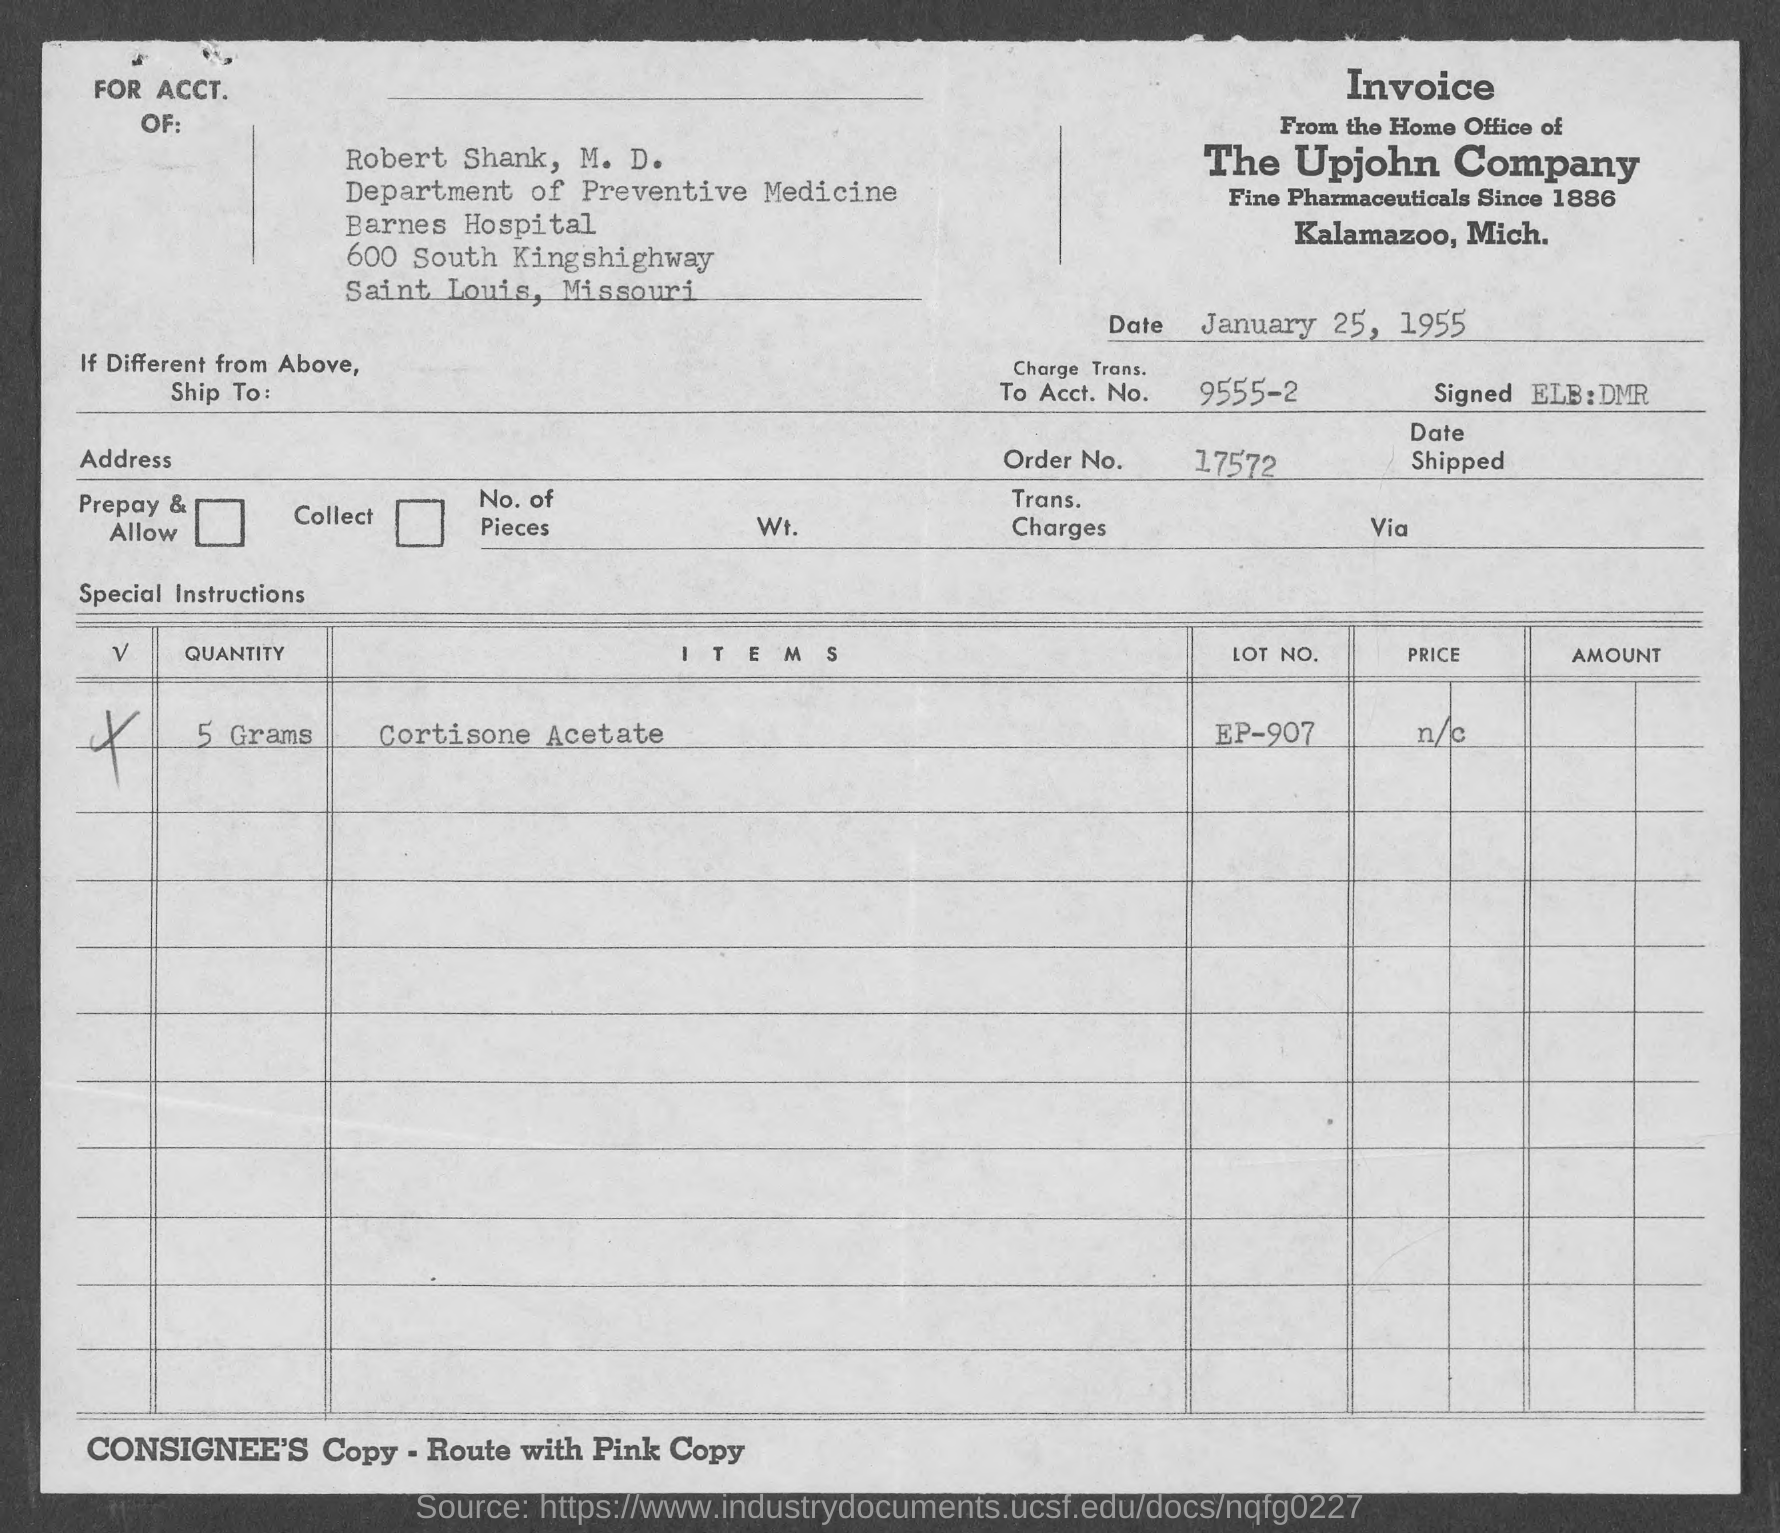From which company is the invoice?
Give a very brief answer. The Upjohn Company. When is the document dated?
Offer a very short reply. January 25, 1955. What is the Account Number?
Make the answer very short. 9555-2. What is the order no.?
Your response must be concise. 17572. What is the item mentioned?
Make the answer very short. Cortisone Acetate. What is the quantity specified?
Offer a terse response. 5 Grams. What is the LOT NO.?
Your answer should be very brief. EP-907. 